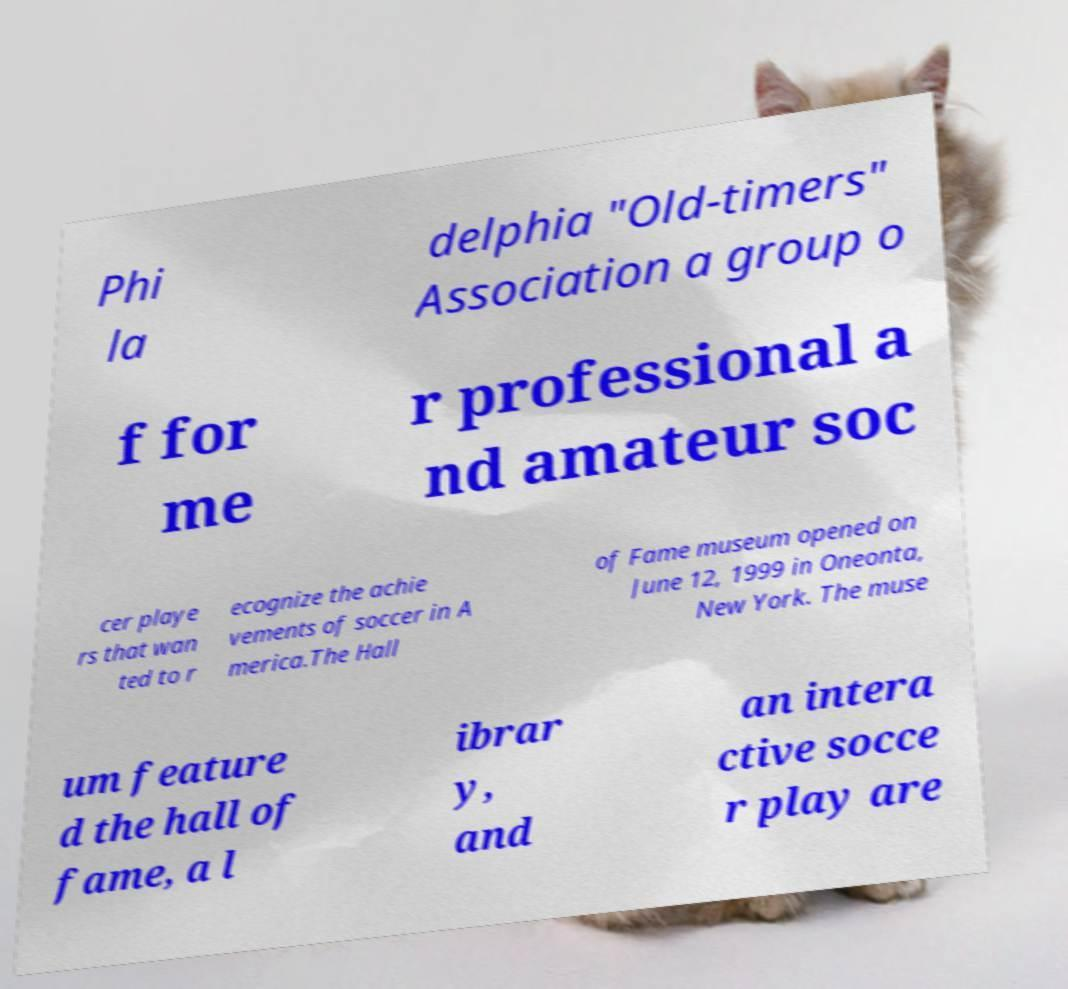For documentation purposes, I need the text within this image transcribed. Could you provide that? Phi la delphia "Old-timers" Association a group o f for me r professional a nd amateur soc cer playe rs that wan ted to r ecognize the achie vements of soccer in A merica.The Hall of Fame museum opened on June 12, 1999 in Oneonta, New York. The muse um feature d the hall of fame, a l ibrar y, and an intera ctive socce r play are 